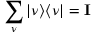<formula> <loc_0><loc_0><loc_500><loc_500>\sum _ { \nu } | \nu \rangle \langle \nu | = I</formula> 